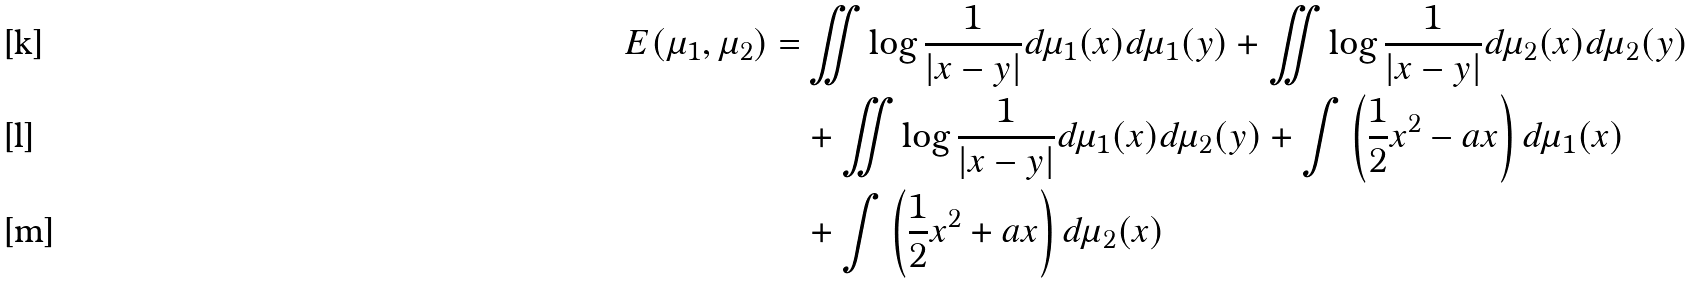Convert formula to latex. <formula><loc_0><loc_0><loc_500><loc_500>E ( \mu _ { 1 } , \mu _ { 2 } ) = & \iint \log \frac { 1 } { | x - y | } d \mu _ { 1 } ( x ) d \mu _ { 1 } ( y ) + \iint \log \frac { 1 } { | x - y | } d \mu _ { 2 } ( x ) d \mu _ { 2 } ( y ) \\ & + \iint \log \frac { 1 } { | x - y | } d \mu _ { 1 } ( x ) d \mu _ { 2 } ( y ) + \int \left ( \frac { 1 } { 2 } x ^ { 2 } - a x \right ) d \mu _ { 1 } ( x ) \\ & + \int \left ( \frac { 1 } { 2 } x ^ { 2 } + a x \right ) d \mu _ { 2 } ( x )</formula> 